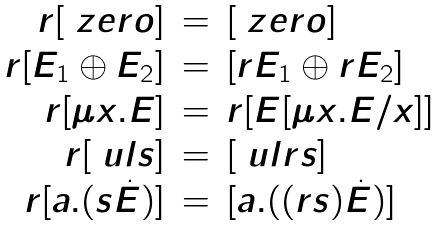Convert formula to latex. <formula><loc_0><loc_0><loc_500><loc_500>\begin{array} { r c l } r [ \ z e r o ] & = & [ \ z e r o ] \\ r [ E _ { 1 } \oplus E _ { 2 } ] & = & [ r E _ { 1 } \oplus r E _ { 2 } ] \\ r [ \mu x . E ] & = & r [ E [ \mu x . E / x ] ] \\ r [ \ u l { s } ] & = & [ \ u l { r s } ] \\ r [ a . ( s \dot { E } ) ] & = & [ a . ( ( r s ) \dot { E } ) ] \end{array}</formula> 